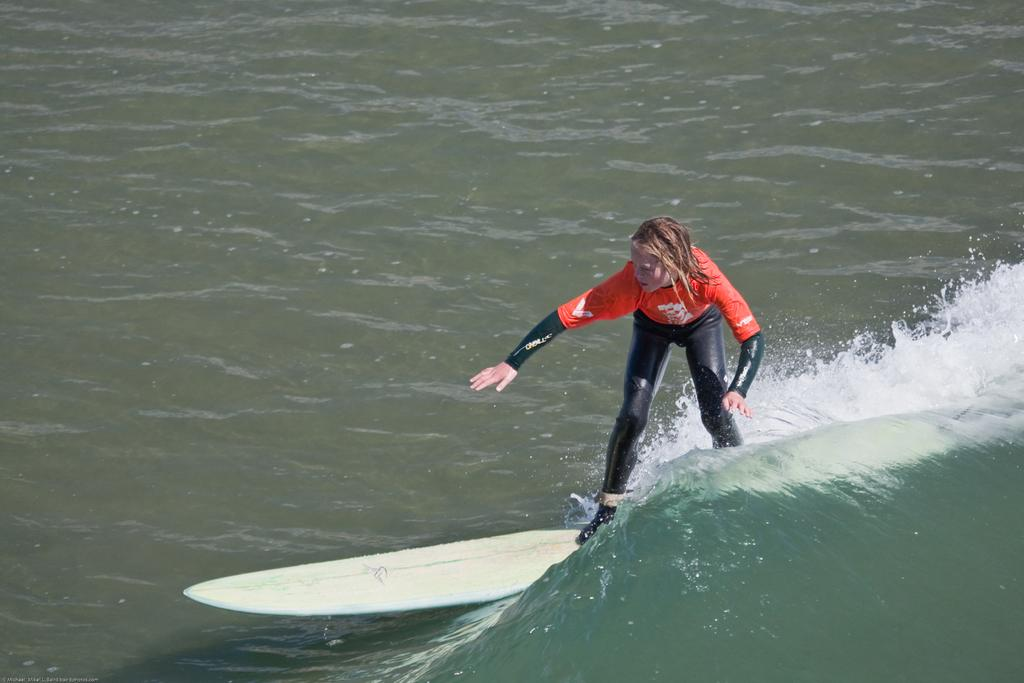What is the person in the image doing? The person in the image is surfing. Where is the surfing taking place? The surfing is taking place on the sea. What type of motion is the quarter performing in the image? There is no quarter present in the image, as it features a person surfing on the sea. What type of beast can be seen swimming alongside the surfer in the image? There is no beast present in the image; it only features a person surfing on the sea. 